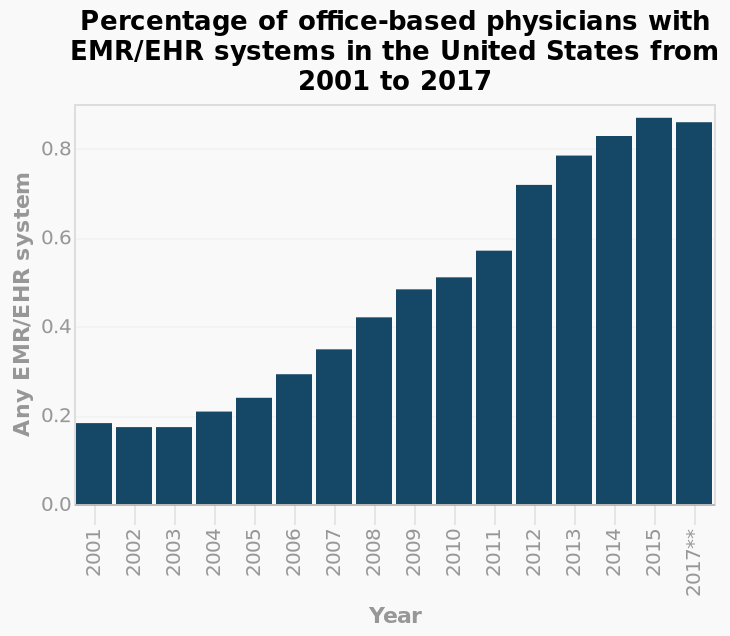<image>
What is the percentage of office-based physicians in 2016? The data for the percentage of office-based physicians in 2016 is not available. please summary the statistics and relations of the chart Between 2001-2003 percentage of office based physicians remained stable at 0.2. Steady increase from 2004 to 2011 rising to 0.6. 2012 saw the biggest year increase to 0.8 in one year. Data for 2016 is not available. What is the timeframe covered in the bar graph?  The bar graph covers the years from 2001 to 2017. 